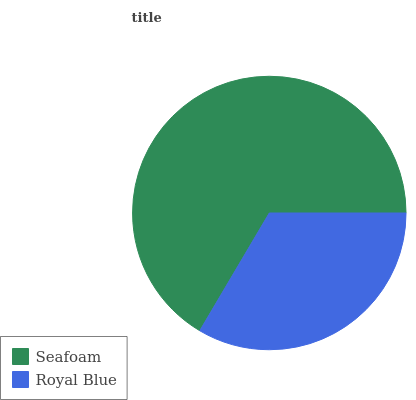Is Royal Blue the minimum?
Answer yes or no. Yes. Is Seafoam the maximum?
Answer yes or no. Yes. Is Royal Blue the maximum?
Answer yes or no. No. Is Seafoam greater than Royal Blue?
Answer yes or no. Yes. Is Royal Blue less than Seafoam?
Answer yes or no. Yes. Is Royal Blue greater than Seafoam?
Answer yes or no. No. Is Seafoam less than Royal Blue?
Answer yes or no. No. Is Seafoam the high median?
Answer yes or no. Yes. Is Royal Blue the low median?
Answer yes or no. Yes. Is Royal Blue the high median?
Answer yes or no. No. Is Seafoam the low median?
Answer yes or no. No. 